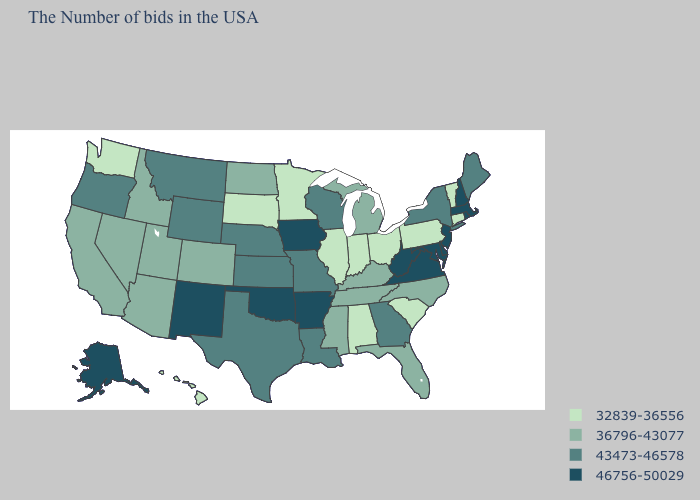Name the states that have a value in the range 43473-46578?
Write a very short answer. Maine, New York, Georgia, Wisconsin, Louisiana, Missouri, Kansas, Nebraska, Texas, Wyoming, Montana, Oregon. Does New Hampshire have the highest value in the USA?
Give a very brief answer. Yes. Does the first symbol in the legend represent the smallest category?
Short answer required. Yes. What is the highest value in states that border South Carolina?
Give a very brief answer. 43473-46578. Does the first symbol in the legend represent the smallest category?
Keep it brief. Yes. What is the value of Mississippi?
Give a very brief answer. 36796-43077. What is the highest value in the USA?
Concise answer only. 46756-50029. What is the lowest value in states that border Rhode Island?
Answer briefly. 32839-36556. Does the map have missing data?
Short answer required. No. Name the states that have a value in the range 32839-36556?
Give a very brief answer. Vermont, Connecticut, Pennsylvania, South Carolina, Ohio, Indiana, Alabama, Illinois, Minnesota, South Dakota, Washington, Hawaii. Does Indiana have the lowest value in the MidWest?
Answer briefly. Yes. What is the highest value in the South ?
Keep it brief. 46756-50029. Does the first symbol in the legend represent the smallest category?
Answer briefly. Yes. What is the value of Rhode Island?
Keep it brief. 46756-50029. What is the value of New Jersey?
Give a very brief answer. 46756-50029. 